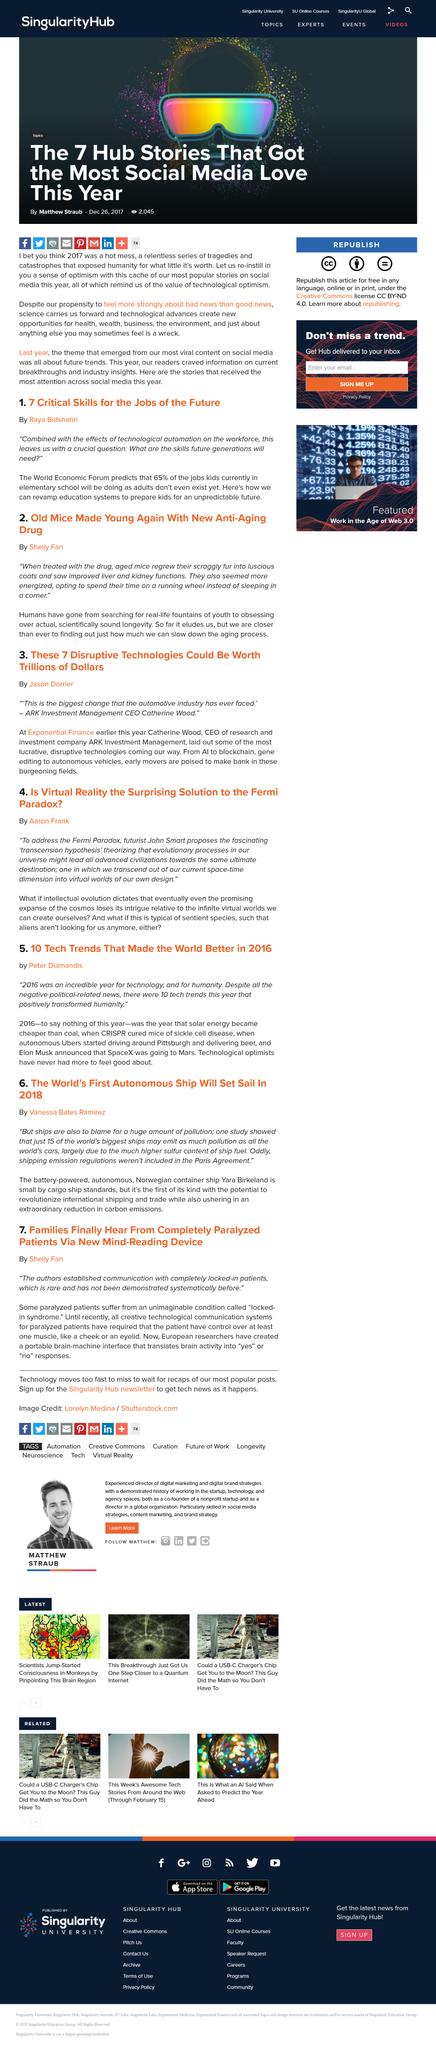Point out several critical features in this image. The Yara Birkeland is the name of the world's first autonomous ship. The upcoming technologies that are expected to make a significant impact in the near future include Artificial Intelligence, Blockchain, gene editing, and autonomous vehicles. CRISPR was used to cure mice of sickle cell disease in 2016. The transcension hypothesis was proposed by futurist John Smart. This new device can translate brain activity into "yes" or "no" responses. 